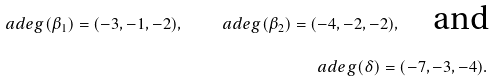Convert formula to latex. <formula><loc_0><loc_0><loc_500><loc_500>\ a d e g ( \beta _ { 1 } ) = ( - 3 , - 1 , - 2 ) , \quad \ a d e g ( \beta _ { 2 } ) = ( - 4 , - 2 , - 2 ) , \quad \text {and} \\ \ a d e g ( \delta ) = ( - 7 , - 3 , - 4 ) .</formula> 